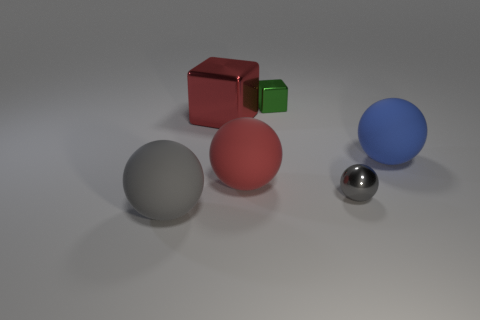Can you describe the atmosphere or mood conveyed by the image? The image conveys a tranquil and subdued atmosphere with its soft lighting and the simple arrangement of geometric objects against the neutral background. The absence of any human presence or movement provides a static, almost meditative quality. The muted colors of the objects, combined with the soft shadows they cast, create a calm and orderly scene. 